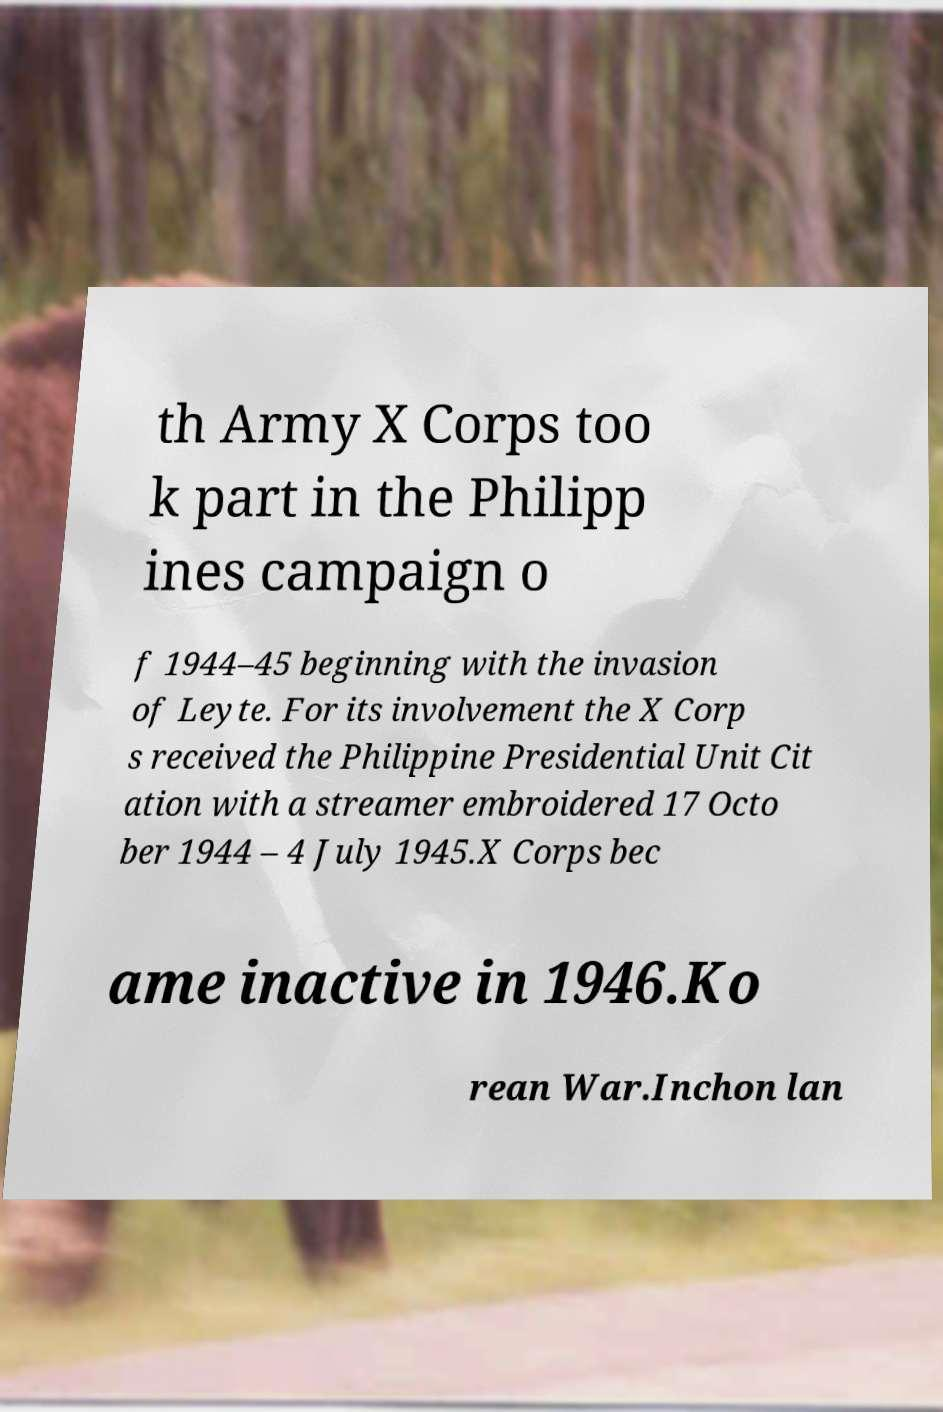Could you extract and type out the text from this image? th Army X Corps too k part in the Philipp ines campaign o f 1944–45 beginning with the invasion of Leyte. For its involvement the X Corp s received the Philippine Presidential Unit Cit ation with a streamer embroidered 17 Octo ber 1944 – 4 July 1945.X Corps bec ame inactive in 1946.Ko rean War.Inchon lan 